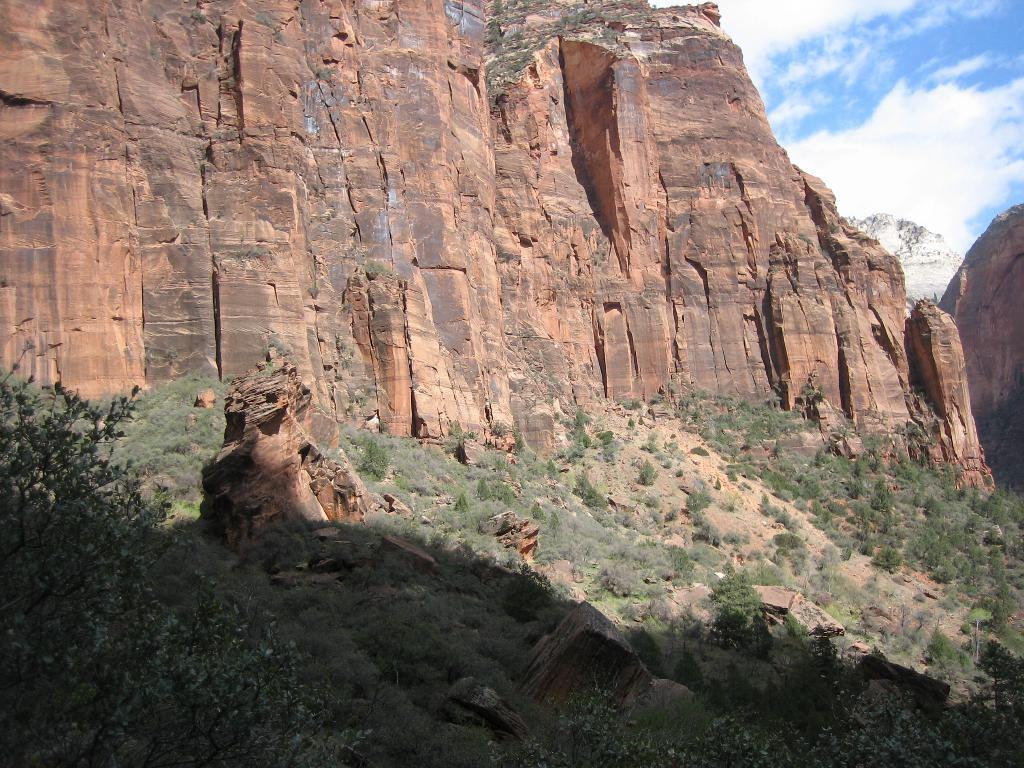What type of living organisms can be seen in the image? There are plants in the image. What color are the plants? The plants are green. What can be seen in the background of the image? There are rocks and mountains in the background of the image. What is the color of the sky in the image? The sky is blue and white in color. What type of silk material is draped over the rocks in the image? There is no silk material present in the image; it features plants, rocks, mountains, and a blue and white sky. Can you tell me how many buckets of water are being used to water the plants in the image? There is no indication of any buckets or watering in the image; it simply shows plants, rocks, mountains, and a blue and white sky. 